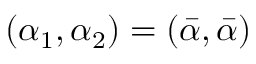<formula> <loc_0><loc_0><loc_500><loc_500>( \alpha _ { 1 } , \alpha _ { 2 } ) = ( \bar { \alpha } , \bar { \alpha } )</formula> 